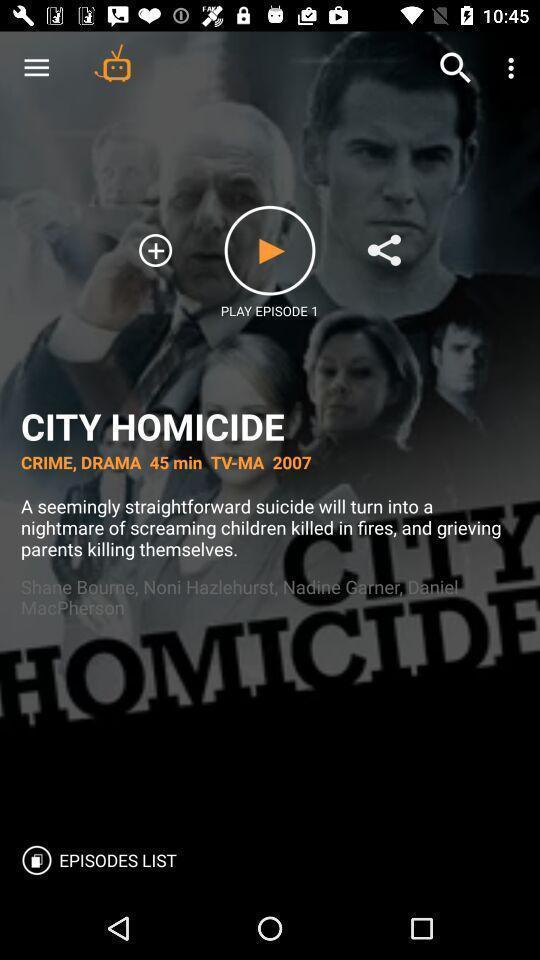Explain the elements present in this screenshot. Window displaying a tv series. 